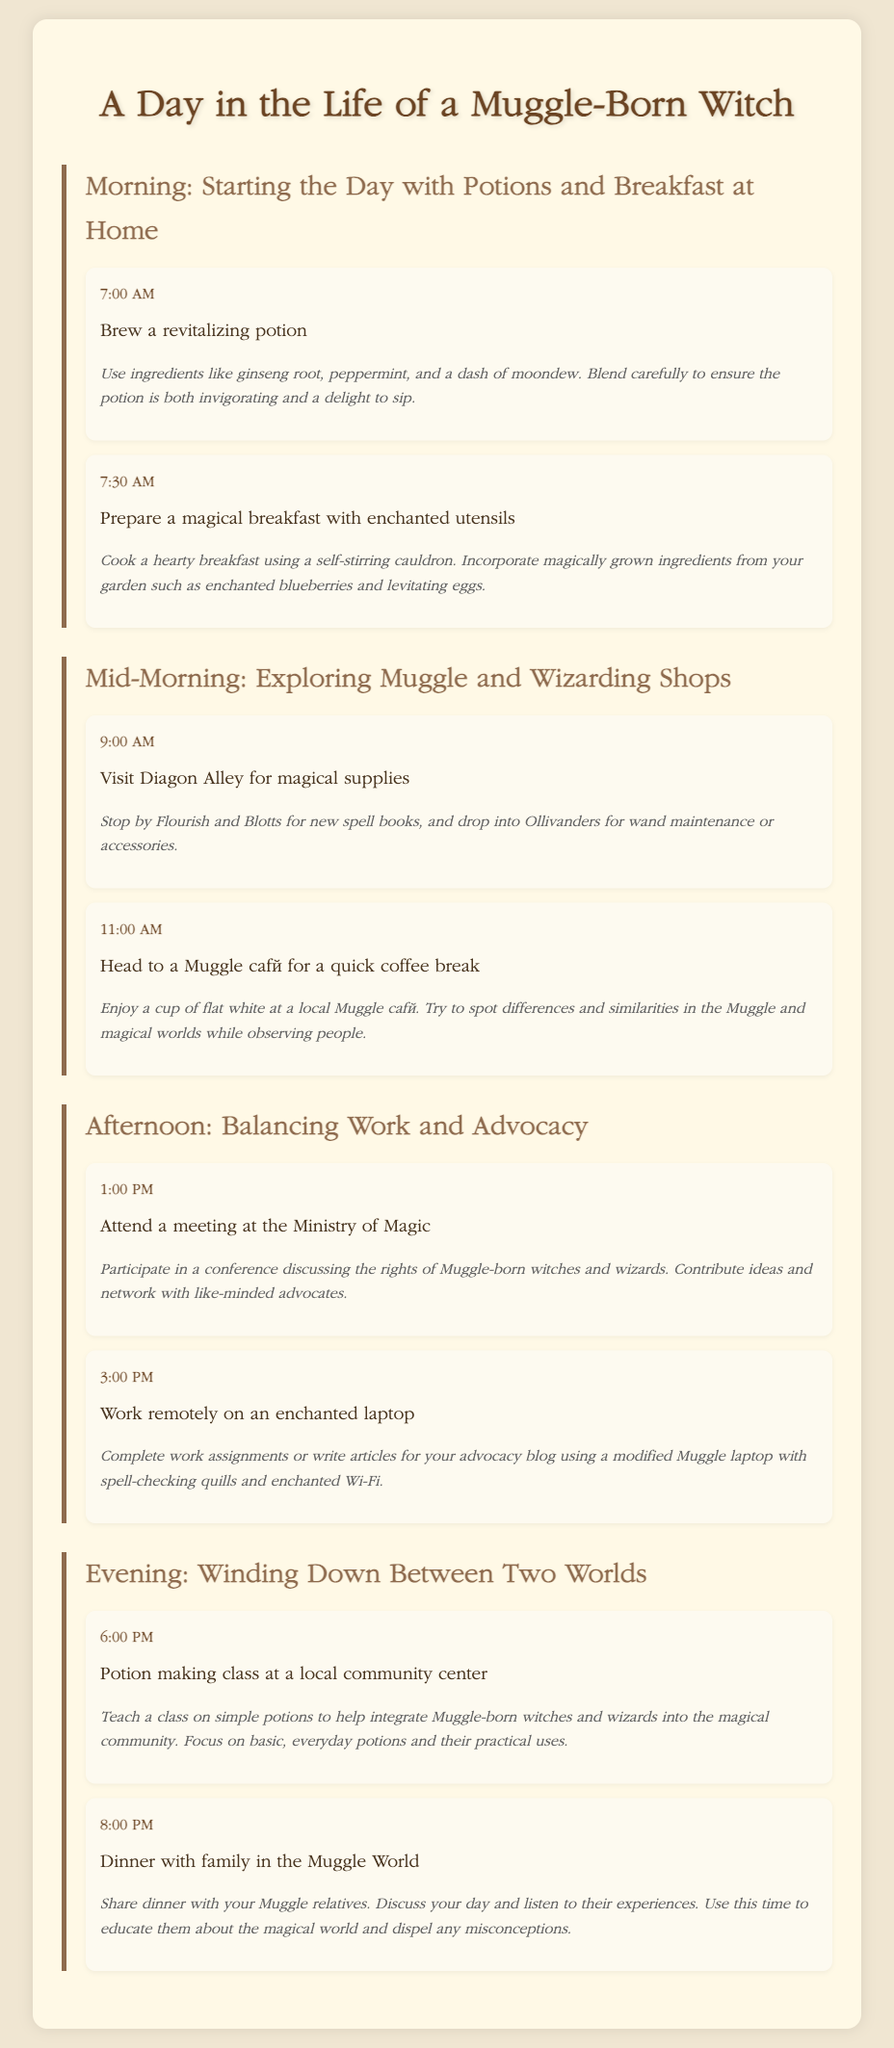What time does the day start for the Muggle-born witch? The starting time is mentioned as 7:00 AM in the morning section of the itinerary.
Answer: 7:00 AM What is the first activity of the day? The first activity listed at 7:00 AM involves brewing a revitalizing potion.
Answer: Brew a revitalizing potion Which location is visited to buy magical supplies? The document specifies visiting Diagon Alley to acquire magical supplies as part of the mid-morning activities.
Answer: Diagon Alley What time is the meeting at the Ministry of Magic scheduled? The meeting is marked at 1:00 PM in the afternoon section under advocacy activities.
Answer: 1:00 PM What type of class is conducted in the evening? The itinerary mentions teaching a potion making class at a community center during the evening activities.
Answer: Potion making class How does the Muggle-born witch utilize an enchanted laptop? The enchanted laptop is used for completing work assignments or writing articles, as stated in the afternoon section.
Answer: Work assignments or writing articles What is the focus of the potion making class? The focus is on simple potions to help integrate Muggle-born witches and wizards into the magical community, as described in the evening section.
Answer: Simple potions What dish do they share during dinner with family? The specific dish is not mentioned, but it involves sharing dinner with Muggle relatives.
Answer: Dinner 